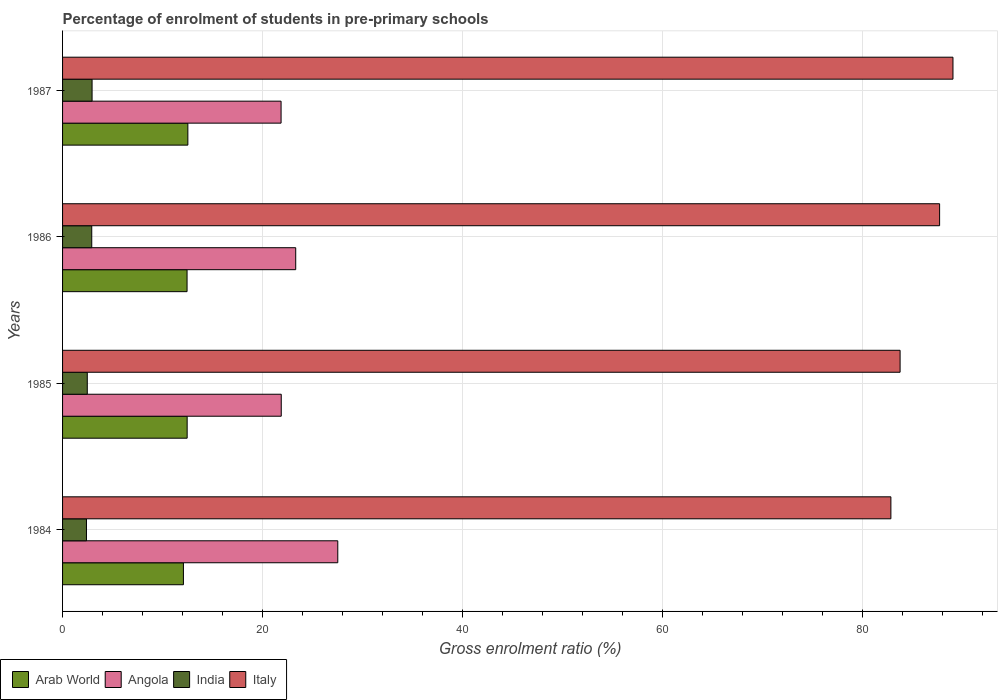How many different coloured bars are there?
Keep it short and to the point. 4. How many groups of bars are there?
Ensure brevity in your answer.  4. Are the number of bars per tick equal to the number of legend labels?
Provide a succinct answer. Yes. Are the number of bars on each tick of the Y-axis equal?
Keep it short and to the point. Yes. How many bars are there on the 1st tick from the top?
Your answer should be very brief. 4. How many bars are there on the 1st tick from the bottom?
Your answer should be very brief. 4. What is the percentage of students enrolled in pre-primary schools in Arab World in 1985?
Your response must be concise. 12.46. Across all years, what is the maximum percentage of students enrolled in pre-primary schools in Angola?
Provide a short and direct response. 27.53. Across all years, what is the minimum percentage of students enrolled in pre-primary schools in Arab World?
Offer a terse response. 12.09. What is the total percentage of students enrolled in pre-primary schools in Italy in the graph?
Your response must be concise. 343.46. What is the difference between the percentage of students enrolled in pre-primary schools in Italy in 1984 and that in 1987?
Provide a short and direct response. -6.21. What is the difference between the percentage of students enrolled in pre-primary schools in Italy in 1987 and the percentage of students enrolled in pre-primary schools in Angola in 1986?
Offer a terse response. 65.75. What is the average percentage of students enrolled in pre-primary schools in Angola per year?
Your answer should be compact. 23.65. In the year 1986, what is the difference between the percentage of students enrolled in pre-primary schools in India and percentage of students enrolled in pre-primary schools in Italy?
Your answer should be compact. -84.82. In how many years, is the percentage of students enrolled in pre-primary schools in Angola greater than 24 %?
Give a very brief answer. 1. What is the ratio of the percentage of students enrolled in pre-primary schools in Italy in 1984 to that in 1985?
Offer a terse response. 0.99. Is the percentage of students enrolled in pre-primary schools in Angola in 1986 less than that in 1987?
Make the answer very short. No. Is the difference between the percentage of students enrolled in pre-primary schools in India in 1984 and 1987 greater than the difference between the percentage of students enrolled in pre-primary schools in Italy in 1984 and 1987?
Your response must be concise. Yes. What is the difference between the highest and the second highest percentage of students enrolled in pre-primary schools in Italy?
Offer a terse response. 1.34. What is the difference between the highest and the lowest percentage of students enrolled in pre-primary schools in Arab World?
Keep it short and to the point. 0.44. In how many years, is the percentage of students enrolled in pre-primary schools in Italy greater than the average percentage of students enrolled in pre-primary schools in Italy taken over all years?
Your answer should be very brief. 2. Is it the case that in every year, the sum of the percentage of students enrolled in pre-primary schools in Arab World and percentage of students enrolled in pre-primary schools in Italy is greater than the sum of percentage of students enrolled in pre-primary schools in Angola and percentage of students enrolled in pre-primary schools in India?
Your answer should be compact. No. What does the 3rd bar from the top in 1986 represents?
Ensure brevity in your answer.  Angola. What does the 1st bar from the bottom in 1987 represents?
Ensure brevity in your answer.  Arab World. Is it the case that in every year, the sum of the percentage of students enrolled in pre-primary schools in Italy and percentage of students enrolled in pre-primary schools in Angola is greater than the percentage of students enrolled in pre-primary schools in India?
Your answer should be compact. Yes. What is the difference between two consecutive major ticks on the X-axis?
Provide a succinct answer. 20. Are the values on the major ticks of X-axis written in scientific E-notation?
Provide a short and direct response. No. Does the graph contain grids?
Give a very brief answer. Yes. How are the legend labels stacked?
Your answer should be compact. Horizontal. What is the title of the graph?
Provide a short and direct response. Percentage of enrolment of students in pre-primary schools. Does "Rwanda" appear as one of the legend labels in the graph?
Provide a short and direct response. No. What is the label or title of the Y-axis?
Ensure brevity in your answer.  Years. What is the Gross enrolment ratio (%) in Arab World in 1984?
Provide a succinct answer. 12.09. What is the Gross enrolment ratio (%) of Angola in 1984?
Ensure brevity in your answer.  27.53. What is the Gross enrolment ratio (%) in India in 1984?
Ensure brevity in your answer.  2.39. What is the Gross enrolment ratio (%) in Italy in 1984?
Your answer should be very brief. 82.86. What is the Gross enrolment ratio (%) in Arab World in 1985?
Offer a terse response. 12.46. What is the Gross enrolment ratio (%) of Angola in 1985?
Keep it short and to the point. 21.88. What is the Gross enrolment ratio (%) in India in 1985?
Offer a terse response. 2.47. What is the Gross enrolment ratio (%) of Italy in 1985?
Give a very brief answer. 83.78. What is the Gross enrolment ratio (%) in Arab World in 1986?
Your response must be concise. 12.45. What is the Gross enrolment ratio (%) of Angola in 1986?
Ensure brevity in your answer.  23.32. What is the Gross enrolment ratio (%) of India in 1986?
Your answer should be very brief. 2.92. What is the Gross enrolment ratio (%) in Italy in 1986?
Give a very brief answer. 87.74. What is the Gross enrolment ratio (%) of Arab World in 1987?
Your answer should be very brief. 12.53. What is the Gross enrolment ratio (%) of Angola in 1987?
Provide a short and direct response. 21.86. What is the Gross enrolment ratio (%) in India in 1987?
Ensure brevity in your answer.  2.95. What is the Gross enrolment ratio (%) of Italy in 1987?
Provide a succinct answer. 89.07. Across all years, what is the maximum Gross enrolment ratio (%) of Arab World?
Make the answer very short. 12.53. Across all years, what is the maximum Gross enrolment ratio (%) in Angola?
Make the answer very short. 27.53. Across all years, what is the maximum Gross enrolment ratio (%) of India?
Provide a succinct answer. 2.95. Across all years, what is the maximum Gross enrolment ratio (%) in Italy?
Offer a very short reply. 89.07. Across all years, what is the minimum Gross enrolment ratio (%) in Arab World?
Your answer should be compact. 12.09. Across all years, what is the minimum Gross enrolment ratio (%) in Angola?
Make the answer very short. 21.86. Across all years, what is the minimum Gross enrolment ratio (%) in India?
Provide a short and direct response. 2.39. Across all years, what is the minimum Gross enrolment ratio (%) in Italy?
Your response must be concise. 82.86. What is the total Gross enrolment ratio (%) in Arab World in the graph?
Your answer should be compact. 49.54. What is the total Gross enrolment ratio (%) in Angola in the graph?
Your answer should be very brief. 94.59. What is the total Gross enrolment ratio (%) of India in the graph?
Make the answer very short. 10.74. What is the total Gross enrolment ratio (%) of Italy in the graph?
Give a very brief answer. 343.46. What is the difference between the Gross enrolment ratio (%) in Arab World in 1984 and that in 1985?
Your response must be concise. -0.37. What is the difference between the Gross enrolment ratio (%) of Angola in 1984 and that in 1985?
Offer a very short reply. 5.66. What is the difference between the Gross enrolment ratio (%) in India in 1984 and that in 1985?
Keep it short and to the point. -0.08. What is the difference between the Gross enrolment ratio (%) of Italy in 1984 and that in 1985?
Keep it short and to the point. -0.92. What is the difference between the Gross enrolment ratio (%) of Arab World in 1984 and that in 1986?
Provide a succinct answer. -0.36. What is the difference between the Gross enrolment ratio (%) of Angola in 1984 and that in 1986?
Offer a terse response. 4.21. What is the difference between the Gross enrolment ratio (%) in India in 1984 and that in 1986?
Provide a succinct answer. -0.53. What is the difference between the Gross enrolment ratio (%) in Italy in 1984 and that in 1986?
Give a very brief answer. -4.87. What is the difference between the Gross enrolment ratio (%) in Arab World in 1984 and that in 1987?
Offer a terse response. -0.44. What is the difference between the Gross enrolment ratio (%) in Angola in 1984 and that in 1987?
Keep it short and to the point. 5.67. What is the difference between the Gross enrolment ratio (%) of India in 1984 and that in 1987?
Your response must be concise. -0.56. What is the difference between the Gross enrolment ratio (%) of Italy in 1984 and that in 1987?
Your response must be concise. -6.21. What is the difference between the Gross enrolment ratio (%) of Arab World in 1985 and that in 1986?
Keep it short and to the point. 0.01. What is the difference between the Gross enrolment ratio (%) of Angola in 1985 and that in 1986?
Ensure brevity in your answer.  -1.45. What is the difference between the Gross enrolment ratio (%) in India in 1985 and that in 1986?
Provide a short and direct response. -0.45. What is the difference between the Gross enrolment ratio (%) of Italy in 1985 and that in 1986?
Offer a terse response. -3.95. What is the difference between the Gross enrolment ratio (%) of Arab World in 1985 and that in 1987?
Ensure brevity in your answer.  -0.07. What is the difference between the Gross enrolment ratio (%) of Angola in 1985 and that in 1987?
Offer a terse response. 0.02. What is the difference between the Gross enrolment ratio (%) of India in 1985 and that in 1987?
Your answer should be compact. -0.48. What is the difference between the Gross enrolment ratio (%) of Italy in 1985 and that in 1987?
Provide a succinct answer. -5.29. What is the difference between the Gross enrolment ratio (%) of Arab World in 1986 and that in 1987?
Ensure brevity in your answer.  -0.08. What is the difference between the Gross enrolment ratio (%) in Angola in 1986 and that in 1987?
Your answer should be compact. 1.46. What is the difference between the Gross enrolment ratio (%) of India in 1986 and that in 1987?
Offer a terse response. -0.03. What is the difference between the Gross enrolment ratio (%) in Italy in 1986 and that in 1987?
Provide a succinct answer. -1.34. What is the difference between the Gross enrolment ratio (%) of Arab World in 1984 and the Gross enrolment ratio (%) of Angola in 1985?
Offer a very short reply. -9.79. What is the difference between the Gross enrolment ratio (%) in Arab World in 1984 and the Gross enrolment ratio (%) in India in 1985?
Your answer should be very brief. 9.62. What is the difference between the Gross enrolment ratio (%) of Arab World in 1984 and the Gross enrolment ratio (%) of Italy in 1985?
Your answer should be compact. -71.69. What is the difference between the Gross enrolment ratio (%) in Angola in 1984 and the Gross enrolment ratio (%) in India in 1985?
Offer a terse response. 25.06. What is the difference between the Gross enrolment ratio (%) in Angola in 1984 and the Gross enrolment ratio (%) in Italy in 1985?
Ensure brevity in your answer.  -56.25. What is the difference between the Gross enrolment ratio (%) of India in 1984 and the Gross enrolment ratio (%) of Italy in 1985?
Give a very brief answer. -81.39. What is the difference between the Gross enrolment ratio (%) in Arab World in 1984 and the Gross enrolment ratio (%) in Angola in 1986?
Offer a very short reply. -11.23. What is the difference between the Gross enrolment ratio (%) in Arab World in 1984 and the Gross enrolment ratio (%) in India in 1986?
Offer a very short reply. 9.17. What is the difference between the Gross enrolment ratio (%) in Arab World in 1984 and the Gross enrolment ratio (%) in Italy in 1986?
Offer a terse response. -75.65. What is the difference between the Gross enrolment ratio (%) in Angola in 1984 and the Gross enrolment ratio (%) in India in 1986?
Ensure brevity in your answer.  24.61. What is the difference between the Gross enrolment ratio (%) in Angola in 1984 and the Gross enrolment ratio (%) in Italy in 1986?
Ensure brevity in your answer.  -60.21. What is the difference between the Gross enrolment ratio (%) of India in 1984 and the Gross enrolment ratio (%) of Italy in 1986?
Ensure brevity in your answer.  -85.35. What is the difference between the Gross enrolment ratio (%) of Arab World in 1984 and the Gross enrolment ratio (%) of Angola in 1987?
Offer a very short reply. -9.77. What is the difference between the Gross enrolment ratio (%) in Arab World in 1984 and the Gross enrolment ratio (%) in India in 1987?
Offer a terse response. 9.14. What is the difference between the Gross enrolment ratio (%) in Arab World in 1984 and the Gross enrolment ratio (%) in Italy in 1987?
Ensure brevity in your answer.  -76.98. What is the difference between the Gross enrolment ratio (%) in Angola in 1984 and the Gross enrolment ratio (%) in India in 1987?
Provide a short and direct response. 24.58. What is the difference between the Gross enrolment ratio (%) of Angola in 1984 and the Gross enrolment ratio (%) of Italy in 1987?
Make the answer very short. -61.54. What is the difference between the Gross enrolment ratio (%) of India in 1984 and the Gross enrolment ratio (%) of Italy in 1987?
Keep it short and to the point. -86.68. What is the difference between the Gross enrolment ratio (%) of Arab World in 1985 and the Gross enrolment ratio (%) of Angola in 1986?
Offer a terse response. -10.86. What is the difference between the Gross enrolment ratio (%) of Arab World in 1985 and the Gross enrolment ratio (%) of India in 1986?
Provide a short and direct response. 9.54. What is the difference between the Gross enrolment ratio (%) in Arab World in 1985 and the Gross enrolment ratio (%) in Italy in 1986?
Ensure brevity in your answer.  -75.27. What is the difference between the Gross enrolment ratio (%) of Angola in 1985 and the Gross enrolment ratio (%) of India in 1986?
Your answer should be compact. 18.96. What is the difference between the Gross enrolment ratio (%) in Angola in 1985 and the Gross enrolment ratio (%) in Italy in 1986?
Offer a terse response. -65.86. What is the difference between the Gross enrolment ratio (%) in India in 1985 and the Gross enrolment ratio (%) in Italy in 1986?
Offer a terse response. -85.27. What is the difference between the Gross enrolment ratio (%) of Arab World in 1985 and the Gross enrolment ratio (%) of Angola in 1987?
Your answer should be compact. -9.4. What is the difference between the Gross enrolment ratio (%) in Arab World in 1985 and the Gross enrolment ratio (%) in India in 1987?
Keep it short and to the point. 9.51. What is the difference between the Gross enrolment ratio (%) of Arab World in 1985 and the Gross enrolment ratio (%) of Italy in 1987?
Offer a very short reply. -76.61. What is the difference between the Gross enrolment ratio (%) of Angola in 1985 and the Gross enrolment ratio (%) of India in 1987?
Provide a succinct answer. 18.92. What is the difference between the Gross enrolment ratio (%) of Angola in 1985 and the Gross enrolment ratio (%) of Italy in 1987?
Your answer should be very brief. -67.2. What is the difference between the Gross enrolment ratio (%) in India in 1985 and the Gross enrolment ratio (%) in Italy in 1987?
Give a very brief answer. -86.6. What is the difference between the Gross enrolment ratio (%) of Arab World in 1986 and the Gross enrolment ratio (%) of Angola in 1987?
Your answer should be very brief. -9.4. What is the difference between the Gross enrolment ratio (%) in Arab World in 1986 and the Gross enrolment ratio (%) in India in 1987?
Provide a short and direct response. 9.5. What is the difference between the Gross enrolment ratio (%) of Arab World in 1986 and the Gross enrolment ratio (%) of Italy in 1987?
Ensure brevity in your answer.  -76.62. What is the difference between the Gross enrolment ratio (%) of Angola in 1986 and the Gross enrolment ratio (%) of India in 1987?
Keep it short and to the point. 20.37. What is the difference between the Gross enrolment ratio (%) in Angola in 1986 and the Gross enrolment ratio (%) in Italy in 1987?
Your response must be concise. -65.75. What is the difference between the Gross enrolment ratio (%) of India in 1986 and the Gross enrolment ratio (%) of Italy in 1987?
Keep it short and to the point. -86.15. What is the average Gross enrolment ratio (%) in Arab World per year?
Provide a succinct answer. 12.39. What is the average Gross enrolment ratio (%) in Angola per year?
Your response must be concise. 23.65. What is the average Gross enrolment ratio (%) in India per year?
Give a very brief answer. 2.68. What is the average Gross enrolment ratio (%) in Italy per year?
Make the answer very short. 85.87. In the year 1984, what is the difference between the Gross enrolment ratio (%) of Arab World and Gross enrolment ratio (%) of Angola?
Your answer should be compact. -15.44. In the year 1984, what is the difference between the Gross enrolment ratio (%) of Arab World and Gross enrolment ratio (%) of India?
Provide a short and direct response. 9.7. In the year 1984, what is the difference between the Gross enrolment ratio (%) of Arab World and Gross enrolment ratio (%) of Italy?
Provide a succinct answer. -70.77. In the year 1984, what is the difference between the Gross enrolment ratio (%) in Angola and Gross enrolment ratio (%) in India?
Provide a succinct answer. 25.14. In the year 1984, what is the difference between the Gross enrolment ratio (%) of Angola and Gross enrolment ratio (%) of Italy?
Provide a short and direct response. -55.33. In the year 1984, what is the difference between the Gross enrolment ratio (%) of India and Gross enrolment ratio (%) of Italy?
Offer a terse response. -80.47. In the year 1985, what is the difference between the Gross enrolment ratio (%) in Arab World and Gross enrolment ratio (%) in Angola?
Give a very brief answer. -9.41. In the year 1985, what is the difference between the Gross enrolment ratio (%) of Arab World and Gross enrolment ratio (%) of India?
Make the answer very short. 9.99. In the year 1985, what is the difference between the Gross enrolment ratio (%) of Arab World and Gross enrolment ratio (%) of Italy?
Provide a succinct answer. -71.32. In the year 1985, what is the difference between the Gross enrolment ratio (%) of Angola and Gross enrolment ratio (%) of India?
Your answer should be very brief. 19.4. In the year 1985, what is the difference between the Gross enrolment ratio (%) in Angola and Gross enrolment ratio (%) in Italy?
Your answer should be very brief. -61.91. In the year 1985, what is the difference between the Gross enrolment ratio (%) of India and Gross enrolment ratio (%) of Italy?
Offer a very short reply. -81.31. In the year 1986, what is the difference between the Gross enrolment ratio (%) of Arab World and Gross enrolment ratio (%) of Angola?
Your response must be concise. -10.87. In the year 1986, what is the difference between the Gross enrolment ratio (%) of Arab World and Gross enrolment ratio (%) of India?
Provide a succinct answer. 9.54. In the year 1986, what is the difference between the Gross enrolment ratio (%) of Arab World and Gross enrolment ratio (%) of Italy?
Make the answer very short. -75.28. In the year 1986, what is the difference between the Gross enrolment ratio (%) in Angola and Gross enrolment ratio (%) in India?
Provide a short and direct response. 20.4. In the year 1986, what is the difference between the Gross enrolment ratio (%) of Angola and Gross enrolment ratio (%) of Italy?
Ensure brevity in your answer.  -64.41. In the year 1986, what is the difference between the Gross enrolment ratio (%) in India and Gross enrolment ratio (%) in Italy?
Provide a short and direct response. -84.82. In the year 1987, what is the difference between the Gross enrolment ratio (%) of Arab World and Gross enrolment ratio (%) of Angola?
Ensure brevity in your answer.  -9.32. In the year 1987, what is the difference between the Gross enrolment ratio (%) in Arab World and Gross enrolment ratio (%) in India?
Your response must be concise. 9.58. In the year 1987, what is the difference between the Gross enrolment ratio (%) in Arab World and Gross enrolment ratio (%) in Italy?
Provide a succinct answer. -76.54. In the year 1987, what is the difference between the Gross enrolment ratio (%) in Angola and Gross enrolment ratio (%) in India?
Your answer should be compact. 18.91. In the year 1987, what is the difference between the Gross enrolment ratio (%) in Angola and Gross enrolment ratio (%) in Italy?
Offer a terse response. -67.22. In the year 1987, what is the difference between the Gross enrolment ratio (%) of India and Gross enrolment ratio (%) of Italy?
Your response must be concise. -86.12. What is the ratio of the Gross enrolment ratio (%) of Arab World in 1984 to that in 1985?
Ensure brevity in your answer.  0.97. What is the ratio of the Gross enrolment ratio (%) in Angola in 1984 to that in 1985?
Ensure brevity in your answer.  1.26. What is the ratio of the Gross enrolment ratio (%) of India in 1984 to that in 1985?
Your response must be concise. 0.97. What is the ratio of the Gross enrolment ratio (%) of Arab World in 1984 to that in 1986?
Give a very brief answer. 0.97. What is the ratio of the Gross enrolment ratio (%) in Angola in 1984 to that in 1986?
Give a very brief answer. 1.18. What is the ratio of the Gross enrolment ratio (%) in India in 1984 to that in 1986?
Offer a very short reply. 0.82. What is the ratio of the Gross enrolment ratio (%) of Italy in 1984 to that in 1986?
Give a very brief answer. 0.94. What is the ratio of the Gross enrolment ratio (%) of Arab World in 1984 to that in 1987?
Give a very brief answer. 0.96. What is the ratio of the Gross enrolment ratio (%) in Angola in 1984 to that in 1987?
Give a very brief answer. 1.26. What is the ratio of the Gross enrolment ratio (%) in India in 1984 to that in 1987?
Offer a terse response. 0.81. What is the ratio of the Gross enrolment ratio (%) of Italy in 1984 to that in 1987?
Keep it short and to the point. 0.93. What is the ratio of the Gross enrolment ratio (%) in Arab World in 1985 to that in 1986?
Ensure brevity in your answer.  1. What is the ratio of the Gross enrolment ratio (%) of Angola in 1985 to that in 1986?
Provide a short and direct response. 0.94. What is the ratio of the Gross enrolment ratio (%) of India in 1985 to that in 1986?
Keep it short and to the point. 0.85. What is the ratio of the Gross enrolment ratio (%) of Italy in 1985 to that in 1986?
Offer a very short reply. 0.95. What is the ratio of the Gross enrolment ratio (%) in India in 1985 to that in 1987?
Keep it short and to the point. 0.84. What is the ratio of the Gross enrolment ratio (%) in Italy in 1985 to that in 1987?
Offer a very short reply. 0.94. What is the ratio of the Gross enrolment ratio (%) of Arab World in 1986 to that in 1987?
Offer a very short reply. 0.99. What is the ratio of the Gross enrolment ratio (%) in Angola in 1986 to that in 1987?
Your answer should be very brief. 1.07. What is the ratio of the Gross enrolment ratio (%) of India in 1986 to that in 1987?
Your answer should be very brief. 0.99. What is the ratio of the Gross enrolment ratio (%) of Italy in 1986 to that in 1987?
Your answer should be very brief. 0.98. What is the difference between the highest and the second highest Gross enrolment ratio (%) in Arab World?
Make the answer very short. 0.07. What is the difference between the highest and the second highest Gross enrolment ratio (%) of Angola?
Make the answer very short. 4.21. What is the difference between the highest and the second highest Gross enrolment ratio (%) of India?
Your answer should be very brief. 0.03. What is the difference between the highest and the second highest Gross enrolment ratio (%) in Italy?
Your answer should be very brief. 1.34. What is the difference between the highest and the lowest Gross enrolment ratio (%) in Arab World?
Ensure brevity in your answer.  0.44. What is the difference between the highest and the lowest Gross enrolment ratio (%) in Angola?
Your answer should be very brief. 5.67. What is the difference between the highest and the lowest Gross enrolment ratio (%) of India?
Give a very brief answer. 0.56. What is the difference between the highest and the lowest Gross enrolment ratio (%) of Italy?
Ensure brevity in your answer.  6.21. 